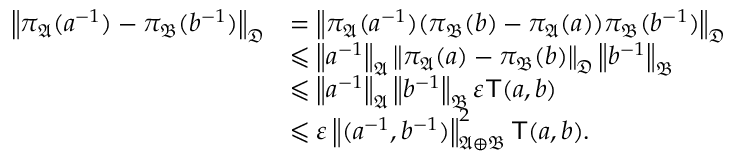Convert formula to latex. <formula><loc_0><loc_0><loc_500><loc_500>\begin{array} { r l } { \left \| { \pi _ { \mathfrak { A } } ( a ^ { - 1 } ) - \pi _ { \mathfrak { B } } ( b ^ { - 1 } ) } \right \| _ { { \mathfrak { D } } } } & { = \left \| { \pi _ { \mathfrak { A } } ( a ^ { - 1 } ) ( \pi _ { \mathfrak { B } } ( b ) - \pi _ { \mathfrak { A } } ( a ) ) \pi _ { \mathfrak { B } } ( b ^ { - 1 } ) } \right \| _ { { \mathfrak { D } } } } \\ & { \leqslant \left \| { a ^ { - 1 } } \right \| _ { { \mathfrak { A } } } \left \| { \pi _ { \mathfrak { A } } ( a ) - \pi _ { \mathfrak { B } } ( b ) } \right \| _ { { \mathfrak { D } } } \left \| { b ^ { - 1 } } \right \| _ { { \mathfrak { B } } } } \\ & { \leqslant \left \| { a ^ { - 1 } } \right \| _ { { \mathfrak { A } } } \left \| { b ^ { - 1 } } \right \| _ { { \mathfrak { B } } } \varepsilon { T } ( a , b ) } \\ & { \leqslant \varepsilon \left \| { ( a ^ { - 1 } , b ^ { - 1 } ) } \right \| _ { { \mathfrak { A } } \oplus { \mathfrak { B } } } ^ { 2 } { T } ( a , b ) . } \end{array}</formula> 